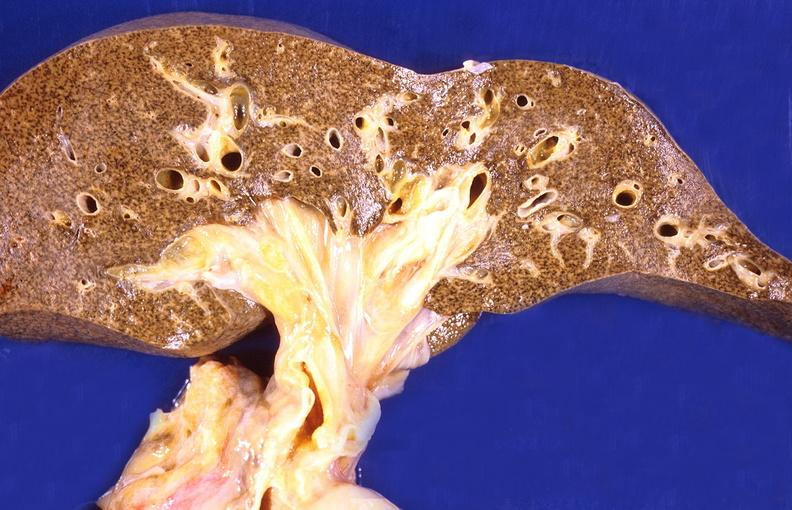does this image show cirrhosis?
Answer the question using a single word or phrase. Yes 